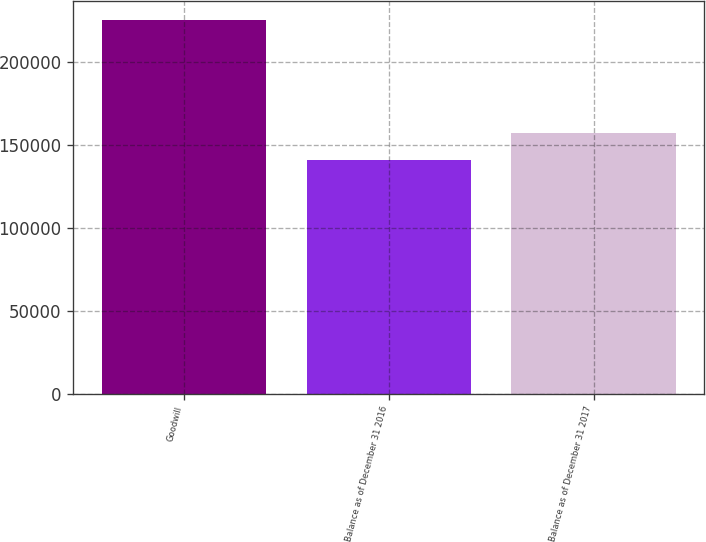Convert chart to OTSL. <chart><loc_0><loc_0><loc_500><loc_500><bar_chart><fcel>Goodwill<fcel>Balance as of December 31 2016<fcel>Balance as of December 31 2017<nl><fcel>225653<fcel>141253<fcel>157289<nl></chart> 